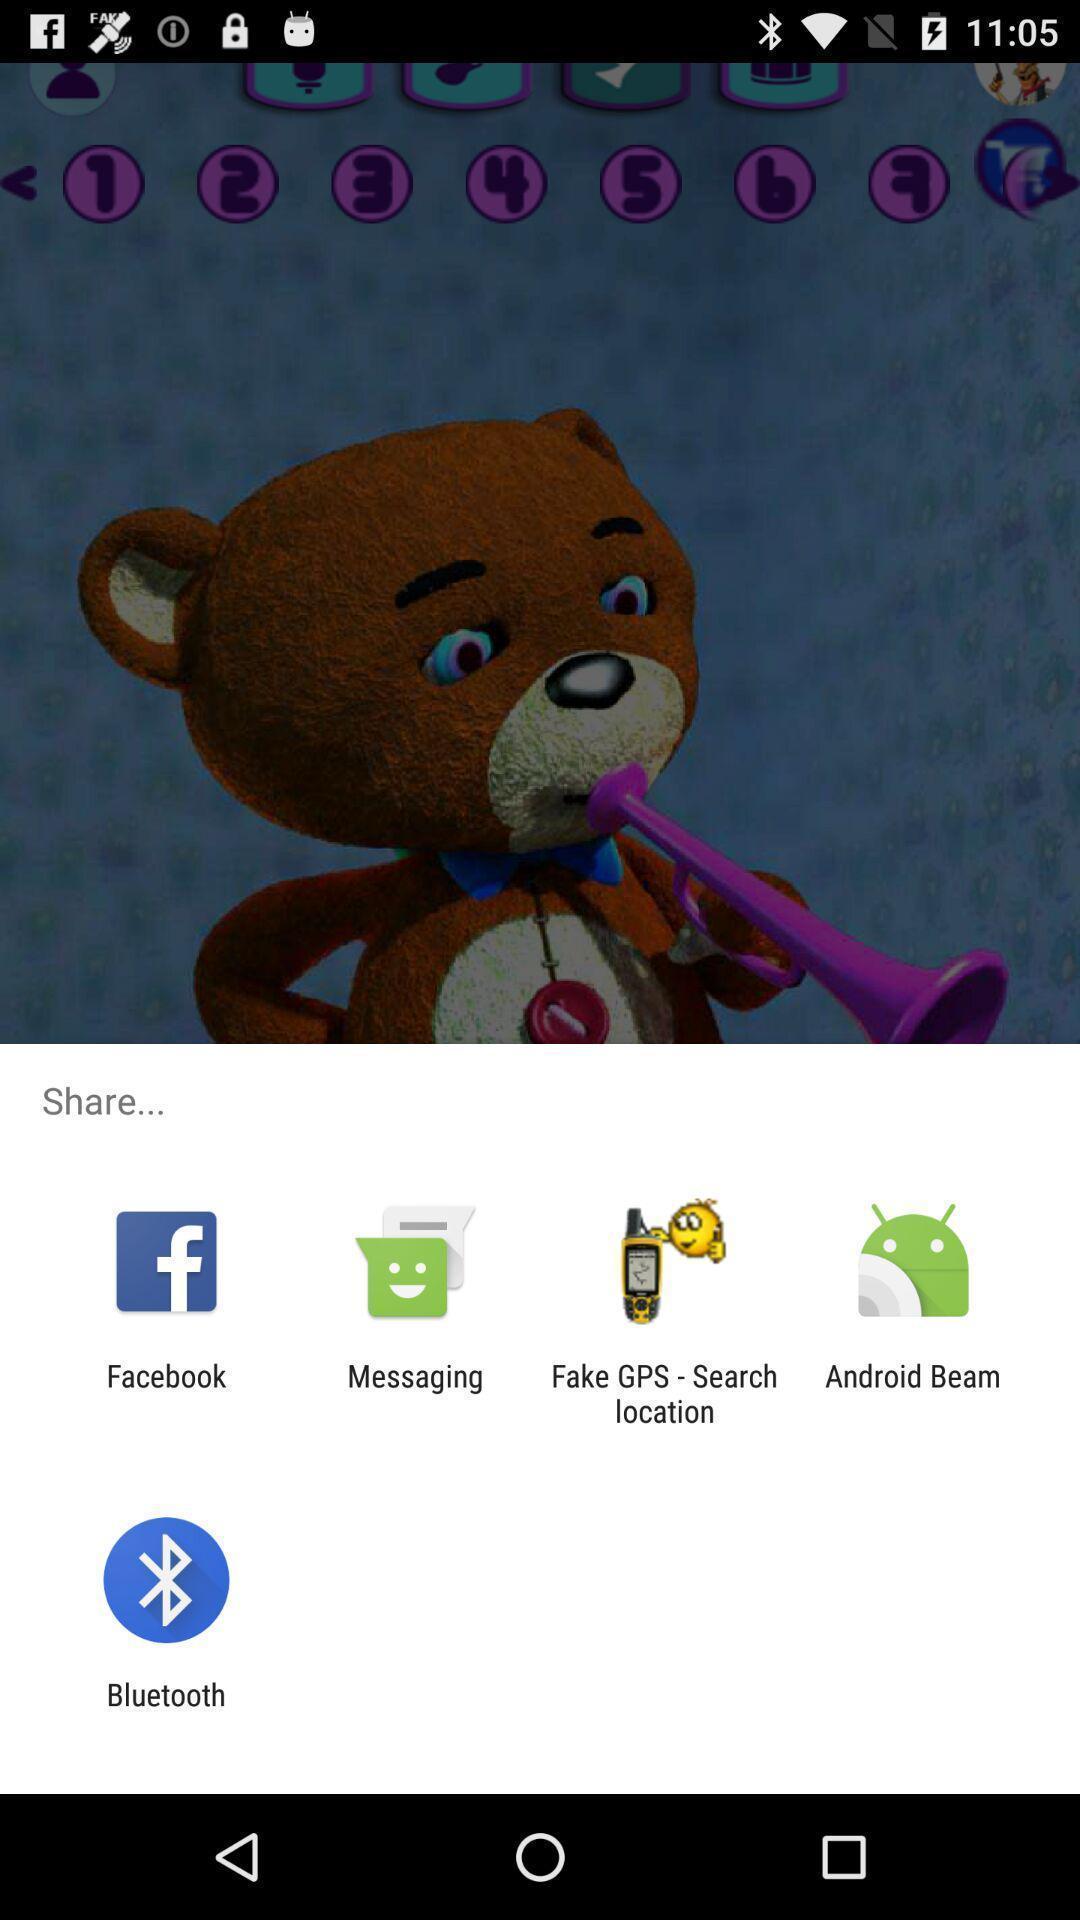Provide a textual representation of this image. Page showing pop-up alert to share. 